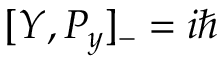<formula> <loc_0><loc_0><loc_500><loc_500>[ Y , P _ { y } ] _ { - } = i \hbar</formula> 